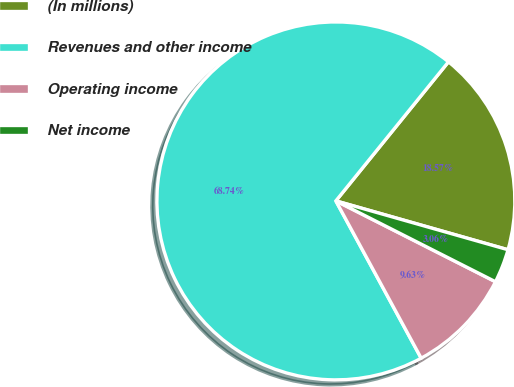<chart> <loc_0><loc_0><loc_500><loc_500><pie_chart><fcel>(In millions)<fcel>Revenues and other income<fcel>Operating income<fcel>Net income<nl><fcel>18.57%<fcel>68.75%<fcel>9.63%<fcel>3.06%<nl></chart> 